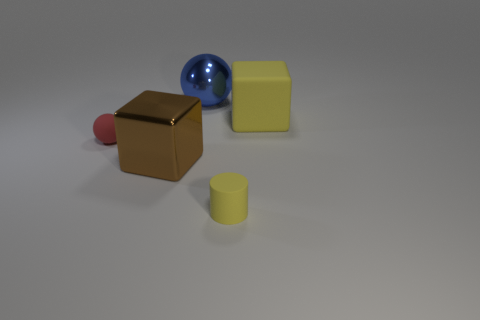How many other things are there of the same shape as the tiny yellow rubber object?
Ensure brevity in your answer.  0. Is there anything else that is the same color as the large ball?
Provide a short and direct response. No. How many other objects are the same size as the matte block?
Keep it short and to the point. 2. What is the material of the large cube that is in front of the rubber object that is behind the small rubber sphere that is on the left side of the yellow matte cylinder?
Give a very brief answer. Metal. Is the material of the yellow block the same as the brown block that is to the left of the yellow cylinder?
Provide a short and direct response. No. Are there fewer big yellow matte cubes on the left side of the big matte block than matte objects on the right side of the cylinder?
Provide a short and direct response. Yes. How many large blocks have the same material as the large blue object?
Provide a short and direct response. 1. There is a yellow object that is to the left of the yellow object that is behind the tiny matte cylinder; is there a block that is left of it?
Your answer should be very brief. Yes. What number of spheres are either big blue metallic things or big yellow metal objects?
Your answer should be very brief. 1. There is a big brown shiny object; is it the same shape as the yellow rubber thing behind the red ball?
Give a very brief answer. Yes. 